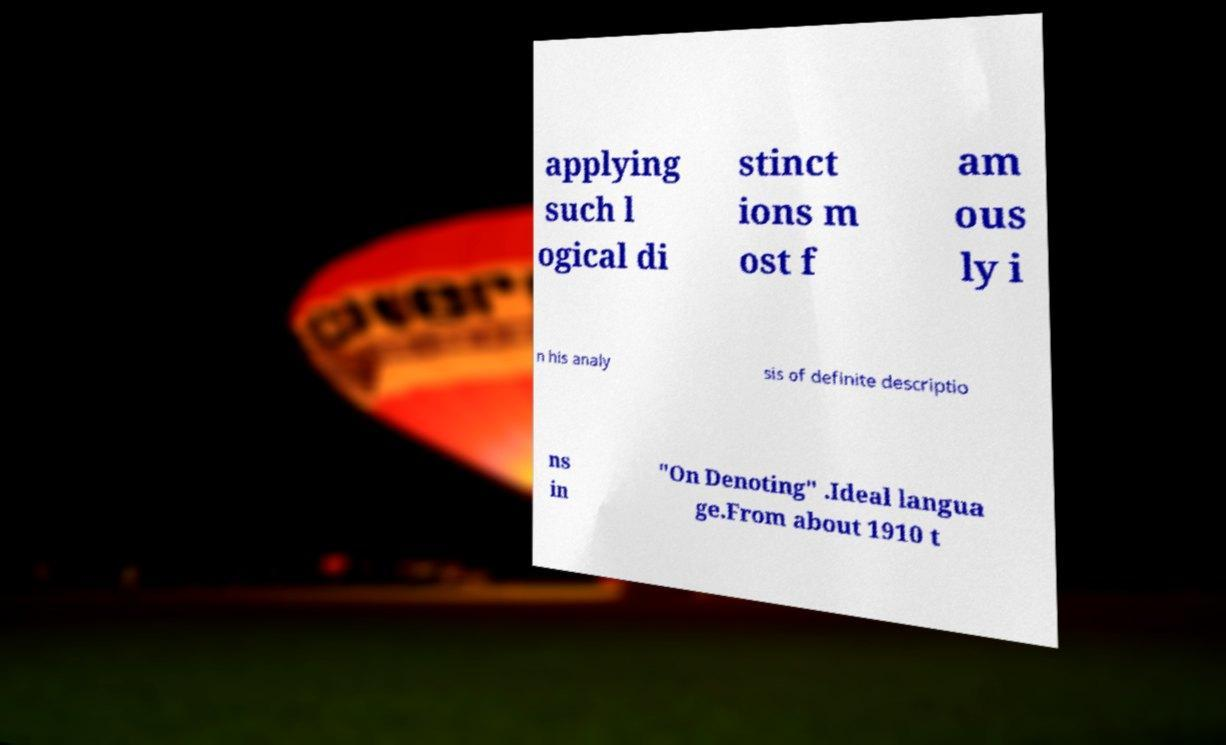Please identify and transcribe the text found in this image. applying such l ogical di stinct ions m ost f am ous ly i n his analy sis of definite descriptio ns in "On Denoting" .Ideal langua ge.From about 1910 t 